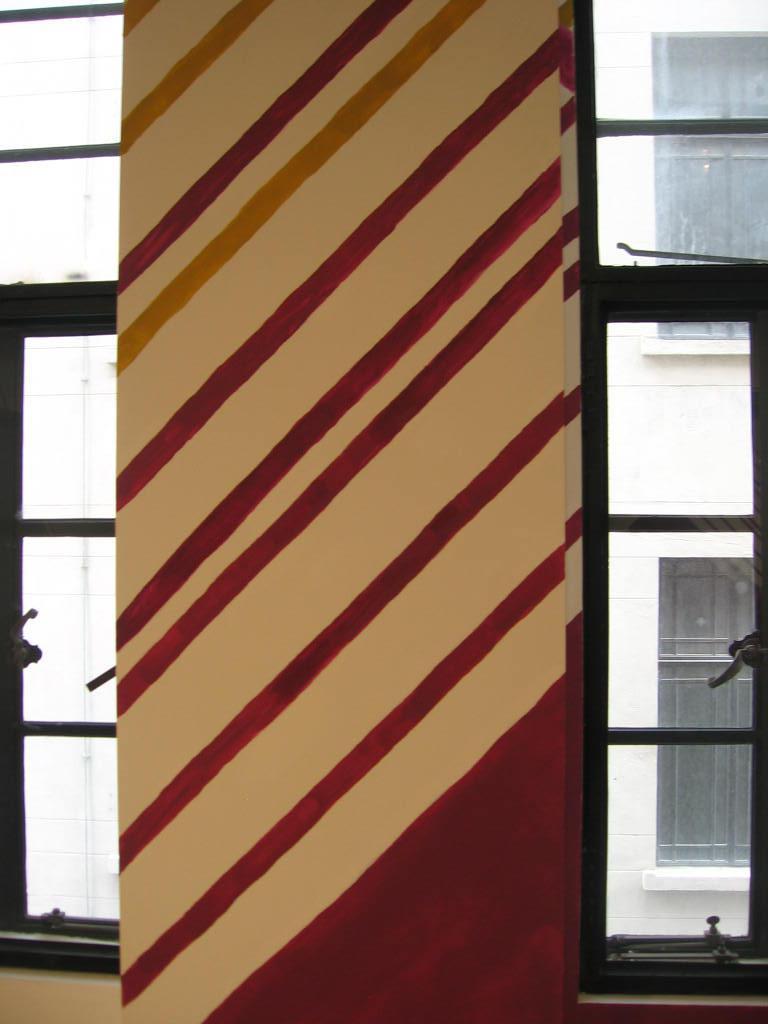How would you summarize this image in a sentence or two? In the center of this picture we can see the few stripes on the pillar. In the background we can see the window and through the window we can see the building and the windows of the building. 